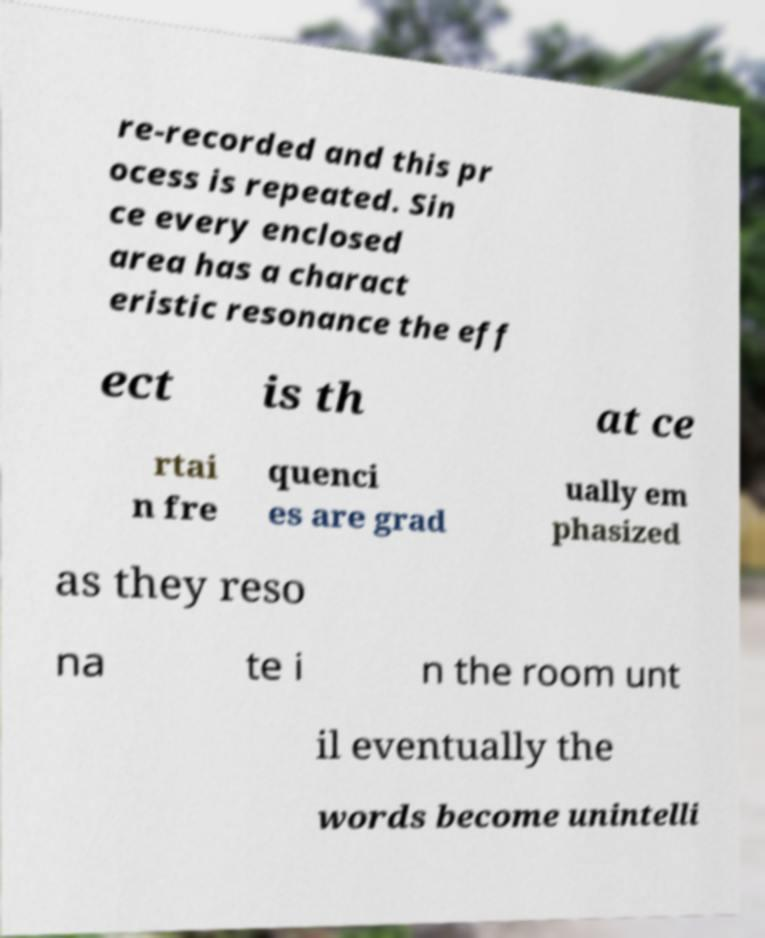Please identify and transcribe the text found in this image. re-recorded and this pr ocess is repeated. Sin ce every enclosed area has a charact eristic resonance the eff ect is th at ce rtai n fre quenci es are grad ually em phasized as they reso na te i n the room unt il eventually the words become unintelli 